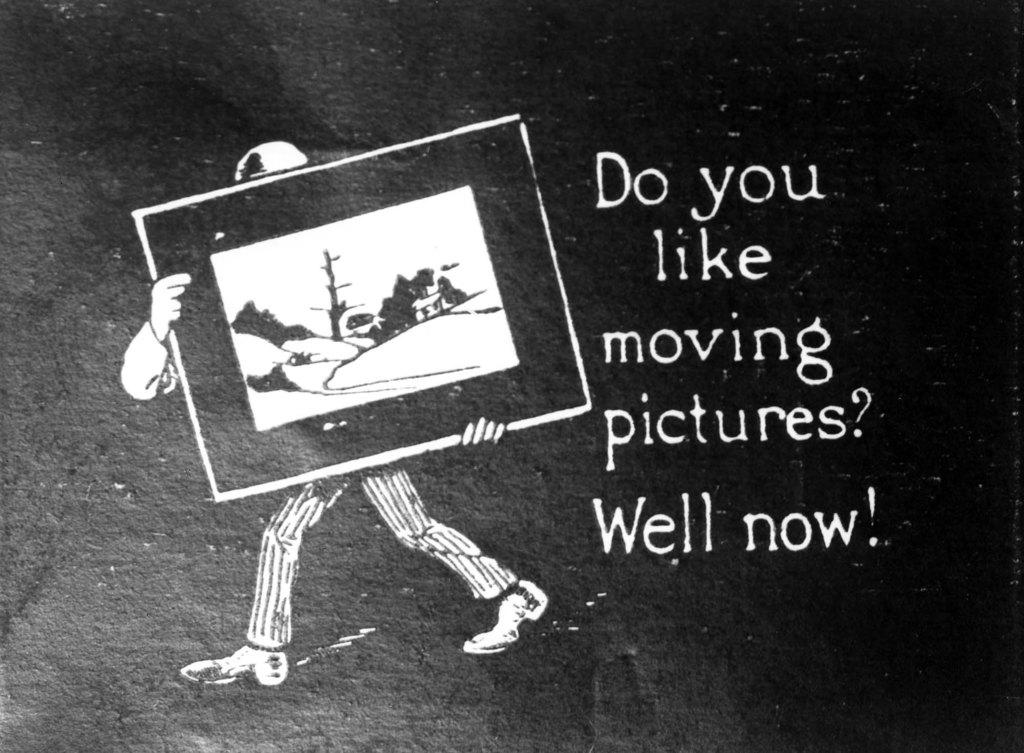What can be found in the image that contains written information? There is some text in the image. What type of visual content is present in the image? There is an art of a person in the image. How many teeth can be seen in the mouth of the person in the image? There is no mouth or teeth visible in the image, as it only features an art of a person and some text. 